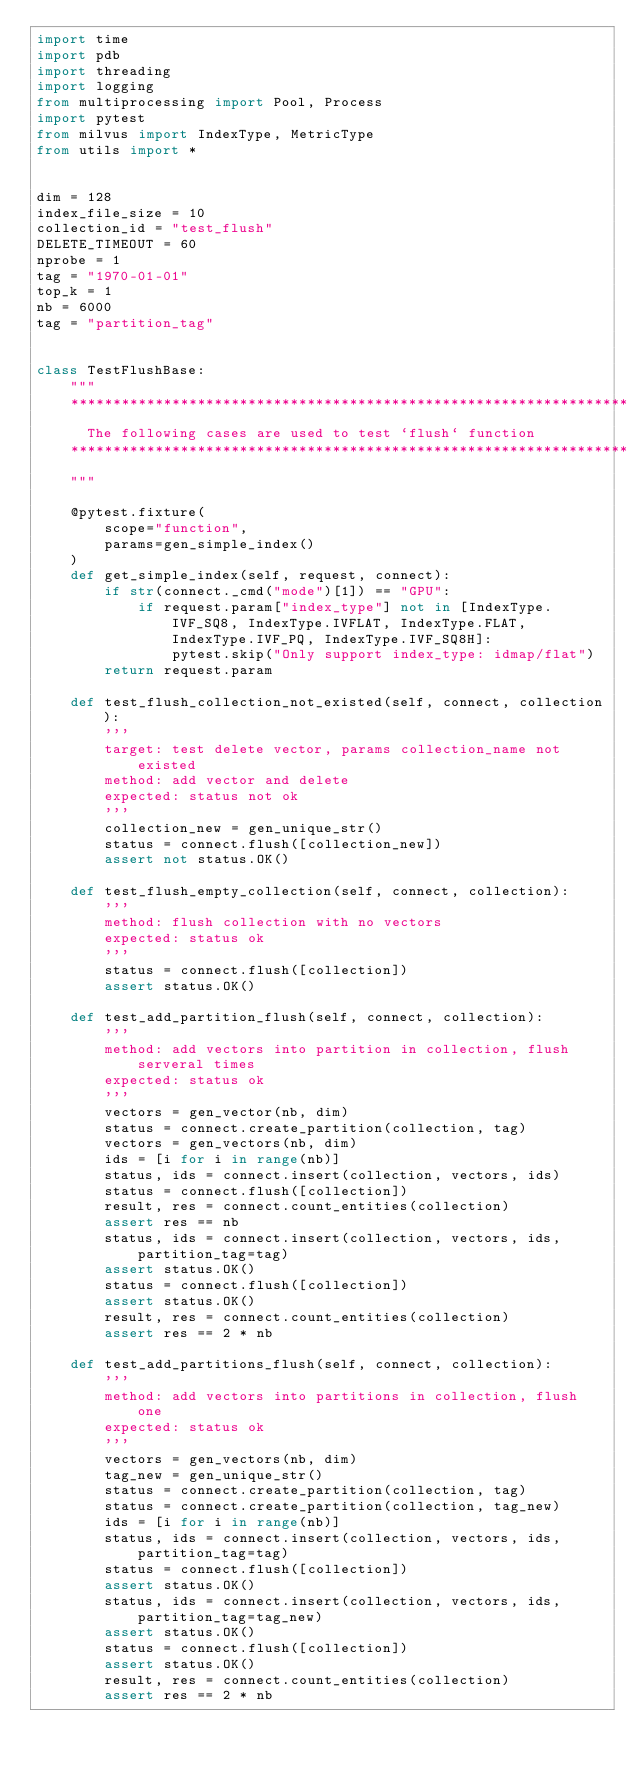<code> <loc_0><loc_0><loc_500><loc_500><_Python_>import time
import pdb
import threading
import logging
from multiprocessing import Pool, Process
import pytest
from milvus import IndexType, MetricType
from utils import *


dim = 128
index_file_size = 10
collection_id = "test_flush"
DELETE_TIMEOUT = 60
nprobe = 1
tag = "1970-01-01"
top_k = 1
nb = 6000
tag = "partition_tag"


class TestFlushBase:
    """
    ******************************************************************
      The following cases are used to test `flush` function
    ******************************************************************
    """

    @pytest.fixture(
        scope="function",
        params=gen_simple_index()
    )
    def get_simple_index(self, request, connect):
        if str(connect._cmd("mode")[1]) == "GPU":
            if request.param["index_type"] not in [IndexType.IVF_SQ8, IndexType.IVFLAT, IndexType.FLAT, IndexType.IVF_PQ, IndexType.IVF_SQ8H]:
                pytest.skip("Only support index_type: idmap/flat")
        return request.param

    def test_flush_collection_not_existed(self, connect, collection):
        '''
        target: test delete vector, params collection_name not existed
        method: add vector and delete
        expected: status not ok
        '''
        collection_new = gen_unique_str()
        status = connect.flush([collection_new])
        assert not status.OK()

    def test_flush_empty_collection(self, connect, collection):
        '''
        method: flush collection with no vectors
        expected: status ok
        '''
        status = connect.flush([collection])
        assert status.OK()

    def test_add_partition_flush(self, connect, collection):
        '''
        method: add vectors into partition in collection, flush serveral times
        expected: status ok
        '''
        vectors = gen_vector(nb, dim)
        status = connect.create_partition(collection, tag)
        vectors = gen_vectors(nb, dim)
        ids = [i for i in range(nb)]
        status, ids = connect.insert(collection, vectors, ids)
        status = connect.flush([collection])
        result, res = connect.count_entities(collection)
        assert res == nb
        status, ids = connect.insert(collection, vectors, ids, partition_tag=tag)
        assert status.OK()
        status = connect.flush([collection])
        assert status.OK()
        result, res = connect.count_entities(collection)
        assert res == 2 * nb

    def test_add_partitions_flush(self, connect, collection):
        '''
        method: add vectors into partitions in collection, flush one
        expected: status ok
        '''
        vectors = gen_vectors(nb, dim)
        tag_new = gen_unique_str()
        status = connect.create_partition(collection, tag)
        status = connect.create_partition(collection, tag_new)
        ids = [i for i in range(nb)]
        status, ids = connect.insert(collection, vectors, ids, partition_tag=tag)
        status = connect.flush([collection])
        assert status.OK()
        status, ids = connect.insert(collection, vectors, ids, partition_tag=tag_new)
        assert status.OK()
        status = connect.flush([collection])
        assert status.OK()
        result, res = connect.count_entities(collection)
        assert res == 2 * nb
</code> 